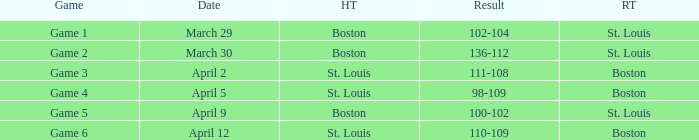What is the number of the game on march 30? Game 2. Could you help me parse every detail presented in this table? {'header': ['Game', 'Date', 'HT', 'Result', 'RT'], 'rows': [['Game 1', 'March 29', 'Boston', '102-104', 'St. Louis'], ['Game 2', 'March 30', 'Boston', '136-112', 'St. Louis'], ['Game 3', 'April 2', 'St. Louis', '111-108', 'Boston'], ['Game 4', 'April 5', 'St. Louis', '98-109', 'Boston'], ['Game 5', 'April 9', 'Boston', '100-102', 'St. Louis'], ['Game 6', 'April 12', 'St. Louis', '110-109', 'Boston']]} 